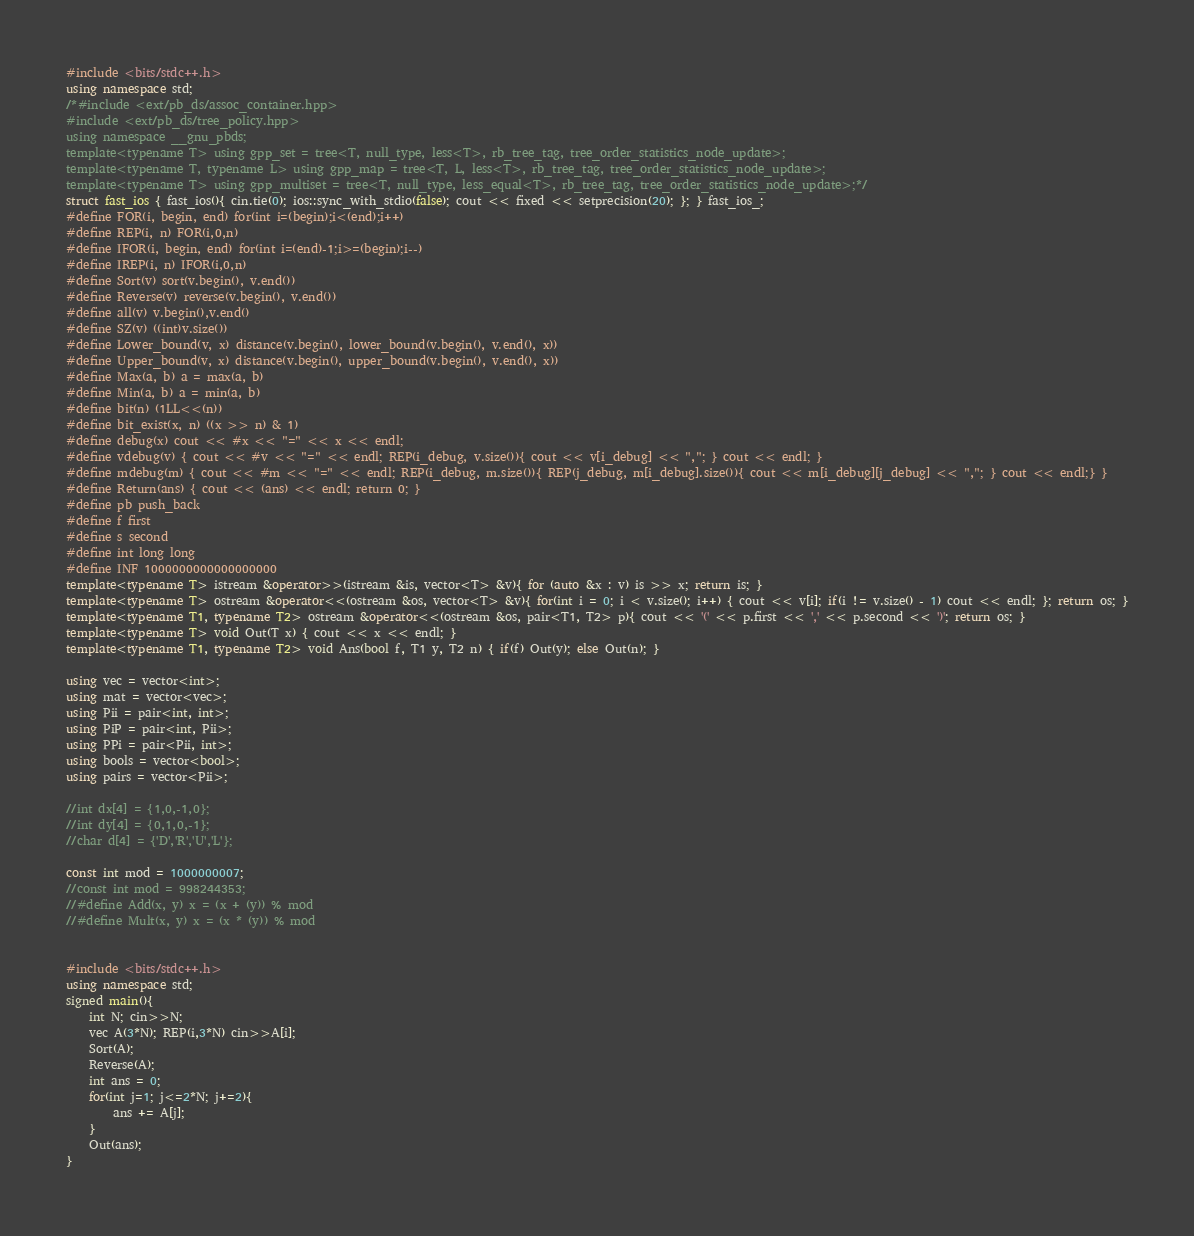Convert code to text. <code><loc_0><loc_0><loc_500><loc_500><_C++_>#include <bits/stdc++.h>
using namespace std;
/*#include <ext/pb_ds/assoc_container.hpp>
#include <ext/pb_ds/tree_policy.hpp>
using namespace __gnu_pbds;
template<typename T> using gpp_set = tree<T, null_type, less<T>, rb_tree_tag, tree_order_statistics_node_update>;
template<typename T, typename L> using gpp_map = tree<T, L, less<T>, rb_tree_tag, tree_order_statistics_node_update>;
template<typename T> using gpp_multiset = tree<T, null_type, less_equal<T>, rb_tree_tag, tree_order_statistics_node_update>;*/
struct fast_ios { fast_ios(){ cin.tie(0); ios::sync_with_stdio(false); cout << fixed << setprecision(20); }; } fast_ios_;
#define FOR(i, begin, end) for(int i=(begin);i<(end);i++)
#define REP(i, n) FOR(i,0,n)
#define IFOR(i, begin, end) for(int i=(end)-1;i>=(begin);i--)
#define IREP(i, n) IFOR(i,0,n)
#define Sort(v) sort(v.begin(), v.end())
#define Reverse(v) reverse(v.begin(), v.end())
#define all(v) v.begin(),v.end()
#define SZ(v) ((int)v.size())
#define Lower_bound(v, x) distance(v.begin(), lower_bound(v.begin(), v.end(), x))
#define Upper_bound(v, x) distance(v.begin(), upper_bound(v.begin(), v.end(), x))
#define Max(a, b) a = max(a, b)
#define Min(a, b) a = min(a, b)
#define bit(n) (1LL<<(n))
#define bit_exist(x, n) ((x >> n) & 1)
#define debug(x) cout << #x << "=" << x << endl;
#define vdebug(v) { cout << #v << "=" << endl; REP(i_debug, v.size()){ cout << v[i_debug] << ","; } cout << endl; }
#define mdebug(m) { cout << #m << "=" << endl; REP(i_debug, m.size()){ REP(j_debug, m[i_debug].size()){ cout << m[i_debug][j_debug] << ","; } cout << endl;} }
#define Return(ans) { cout << (ans) << endl; return 0; }
#define pb push_back
#define f first
#define s second
#define int long long
#define INF 1000000000000000000
template<typename T> istream &operator>>(istream &is, vector<T> &v){ for (auto &x : v) is >> x; return is; }
template<typename T> ostream &operator<<(ostream &os, vector<T> &v){ for(int i = 0; i < v.size(); i++) { cout << v[i]; if(i != v.size() - 1) cout << endl; }; return os; }
template<typename T1, typename T2> ostream &operator<<(ostream &os, pair<T1, T2> p){ cout << '(' << p.first << ',' << p.second << ')'; return os; }
template<typename T> void Out(T x) { cout << x << endl; }
template<typename T1, typename T2> void Ans(bool f, T1 y, T2 n) { if(f) Out(y); else Out(n); }
 
using vec = vector<int>;
using mat = vector<vec>;
using Pii = pair<int, int>;
using PiP = pair<int, Pii>;
using PPi = pair<Pii, int>;
using bools = vector<bool>;
using pairs = vector<Pii>;
 
//int dx[4] = {1,0,-1,0};
//int dy[4] = {0,1,0,-1};
//char d[4] = {'D','R','U','L'};
 
const int mod = 1000000007;
//const int mod = 998244353;
//#define Add(x, y) x = (x + (y)) % mod
//#define Mult(x, y) x = (x * (y)) % mod


#include <bits/stdc++.h>
using namespace std;
signed main(){
    int N; cin>>N;
    vec A(3*N); REP(i,3*N) cin>>A[i];
    Sort(A);
    Reverse(A);
    int ans = 0;
    for(int j=1; j<=2*N; j+=2){
        ans += A[j];
    }
    Out(ans);
}</code> 